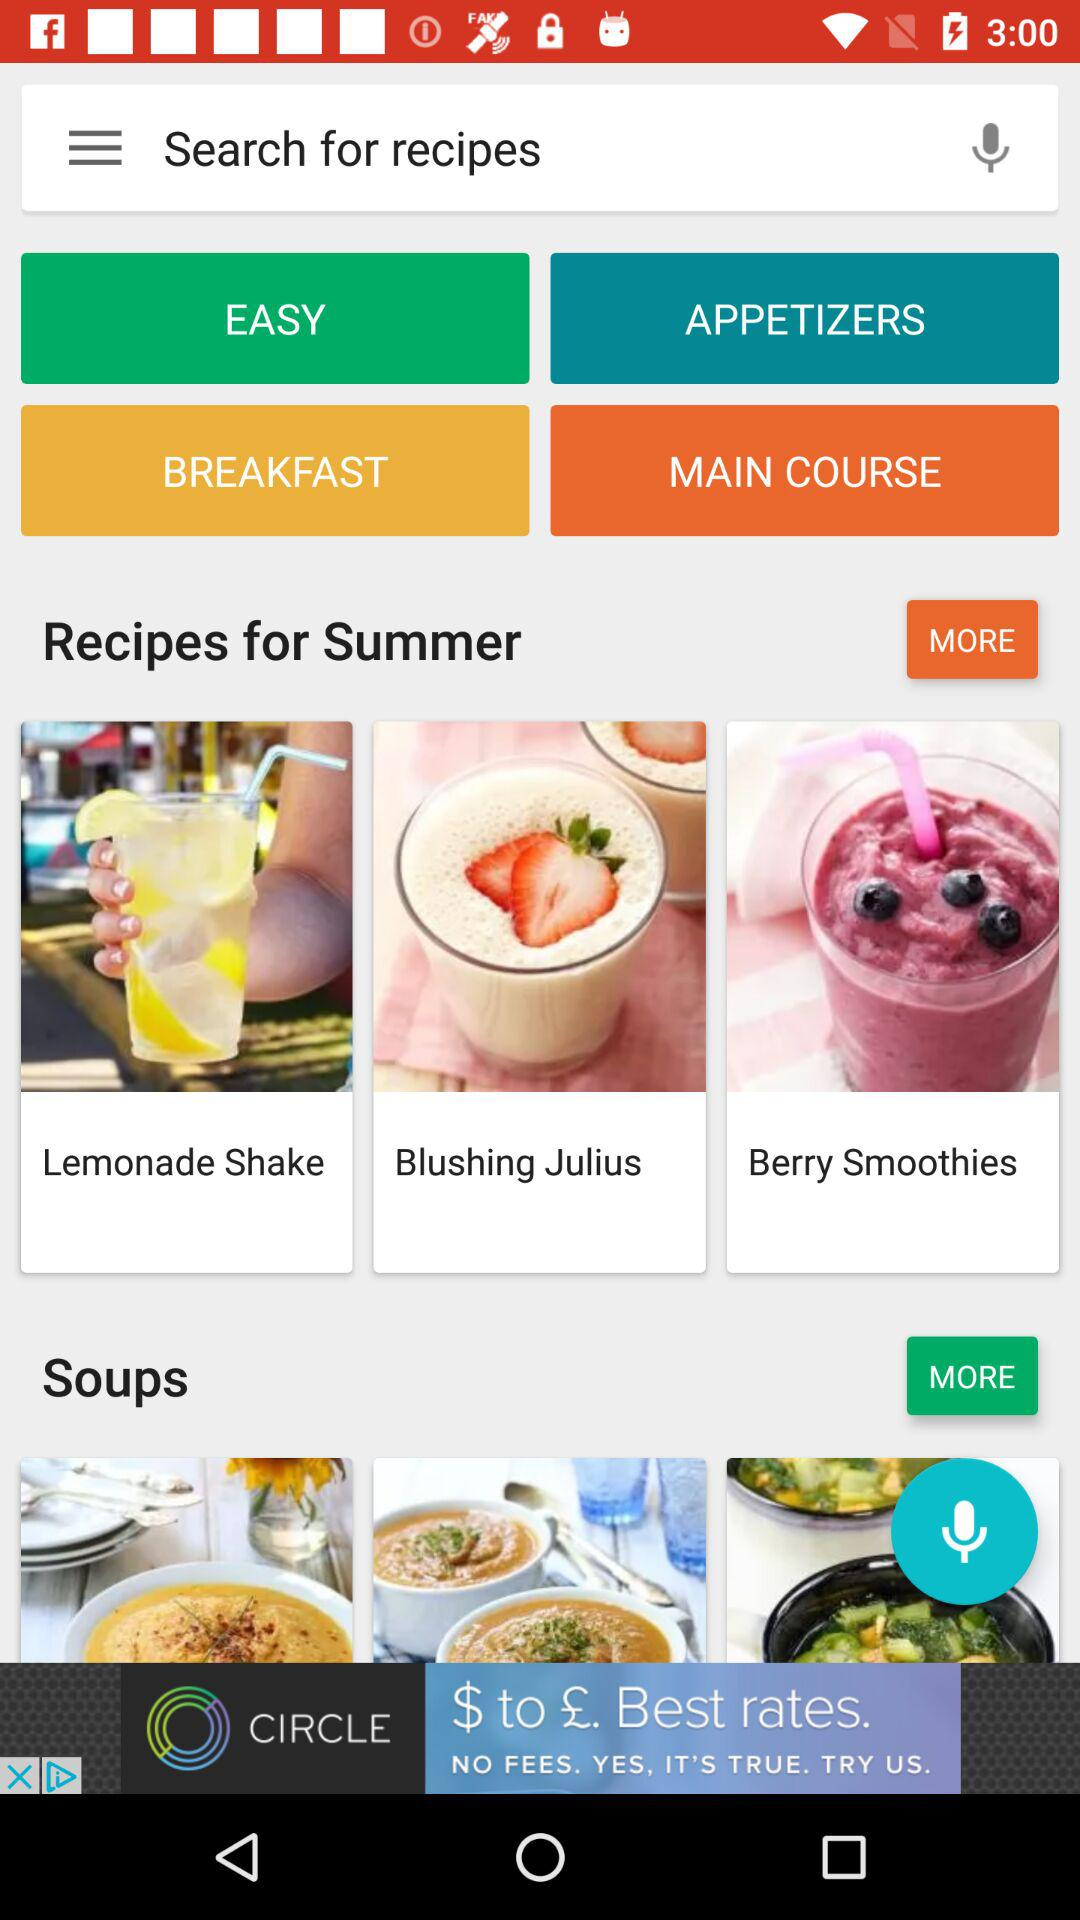What are the available recipes for summer? The available recipes are "Lemonade Shake", "Blushing Julius" and "Berry Smoothies". 